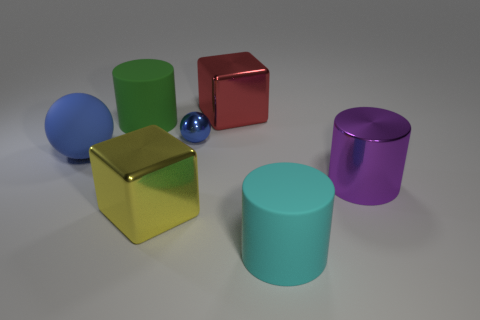How many other objects are the same material as the purple thing?
Your answer should be very brief. 3. Are there more matte cylinders than large red cubes?
Provide a succinct answer. Yes. There is a large matte thing that is behind the tiny ball; does it have the same shape as the cyan object?
Offer a very short reply. Yes. Is the number of green things less than the number of blue objects?
Your response must be concise. Yes. What material is the blue ball that is the same size as the red metallic cube?
Provide a short and direct response. Rubber. There is a small object; does it have the same color as the large matte cylinder in front of the blue matte ball?
Offer a very short reply. No. Is the number of large shiny things that are on the right side of the big red metal object less than the number of red cubes?
Your response must be concise. No. What number of big cyan things are there?
Offer a very short reply. 1. There is a rubber object that is right of the rubber cylinder that is on the left side of the red object; what shape is it?
Ensure brevity in your answer.  Cylinder. There is a small blue thing; how many big cylinders are in front of it?
Offer a terse response. 2. 